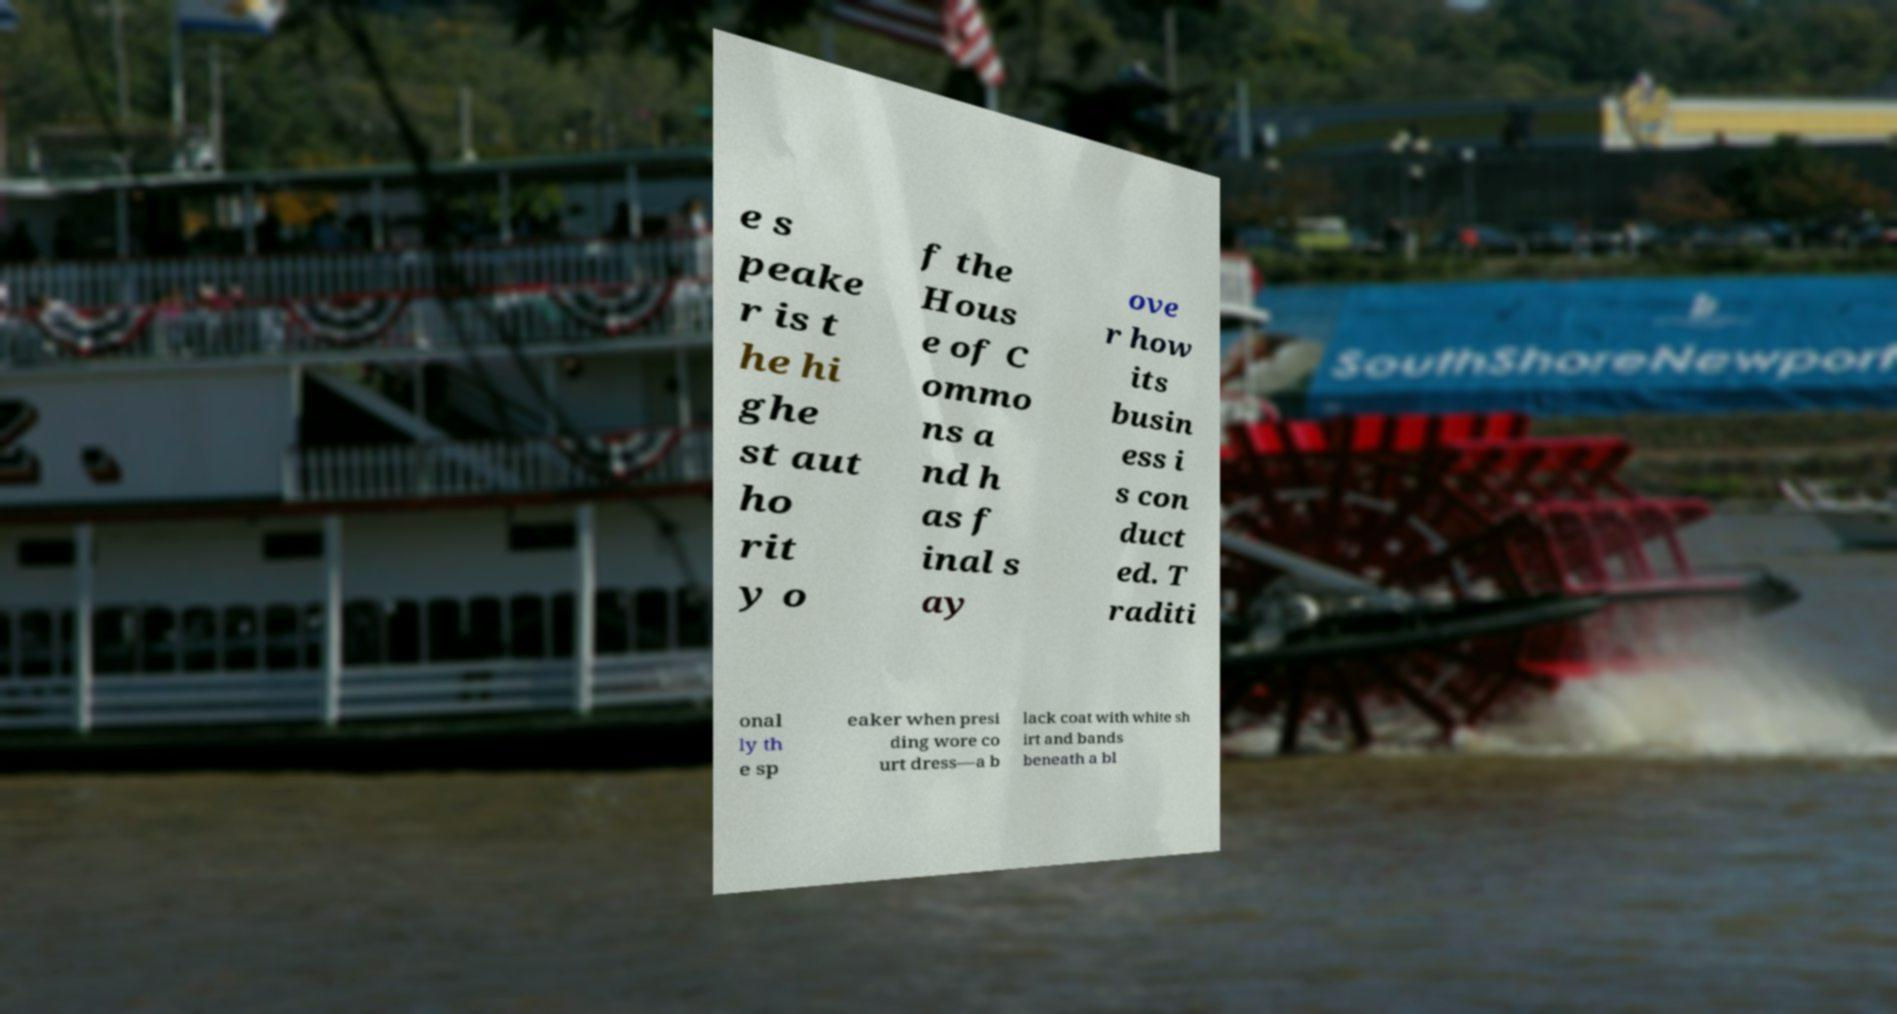Can you accurately transcribe the text from the provided image for me? e s peake r is t he hi ghe st aut ho rit y o f the Hous e of C ommo ns a nd h as f inal s ay ove r how its busin ess i s con duct ed. T raditi onal ly th e sp eaker when presi ding wore co urt dress—a b lack coat with white sh irt and bands beneath a bl 